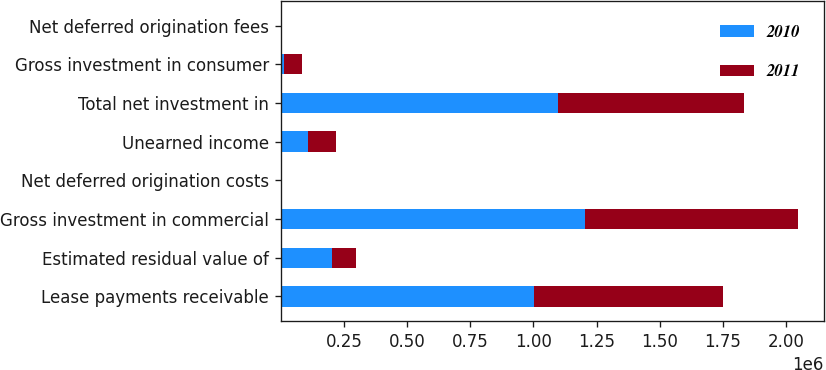Convert chart. <chart><loc_0><loc_0><loc_500><loc_500><stacked_bar_chart><ecel><fcel>Lease payments receivable<fcel>Estimated residual value of<fcel>Gross investment in commercial<fcel>Net deferred origination costs<fcel>Unearned income<fcel>Total net investment in<fcel>Gross investment in consumer<fcel>Net deferred origination fees<nl><fcel>2010<fcel>1.00194e+06<fcel>201663<fcel>1.2036e+06<fcel>3034<fcel>109820<fcel>1.09682e+06<fcel>13405<fcel>18<nl><fcel>2011<fcel>748377<fcel>94665<fcel>843042<fcel>2472<fcel>109962<fcel>735552<fcel>69113<fcel>95<nl></chart> 